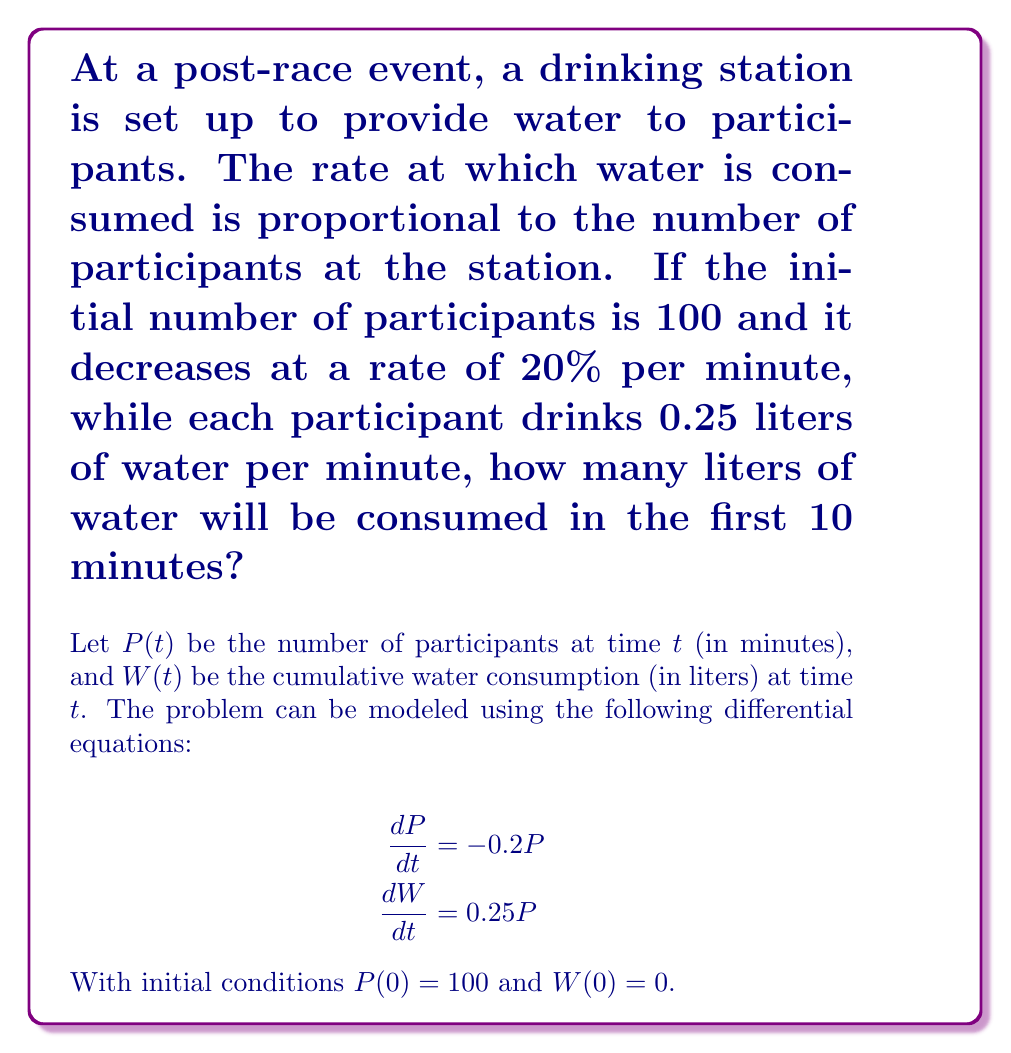Give your solution to this math problem. To solve this problem, we need to follow these steps:

1. Solve the differential equation for $P(t)$:
   $$\frac{dP}{dt} = -0.2P$$
   This is a separable equation. Integrating both sides:
   $$\int \frac{dP}{P} = \int -0.2 dt$$
   $$\ln|P| = -0.2t + C$$
   $$P(t) = Ae^{-0.2t}$$
   Using the initial condition $P(0) = 100$, we get $A = 100$. So:
   $$P(t) = 100e^{-0.2t}$$

2. Now we can solve for $W(t)$:
   $$\frac{dW}{dt} = 0.25P = 0.25(100e^{-0.2t}) = 25e^{-0.2t}$$
   Integrating both sides:
   $$W(t) = \int 25e^{-0.2t} dt = -125e^{-0.2t} + C$$
   Using the initial condition $W(0) = 0$, we get $C = 125$. So:
   $$W(t) = 125 - 125e^{-0.2t}$$

3. To find the water consumed in the first 10 minutes, we calculate $W(10)$:
   $$W(10) = 125 - 125e^{-0.2(10)} \approx 91.79$$

Therefore, approximately 91.79 liters of water will be consumed in the first 10 minutes.
Answer: 91.79 liters 